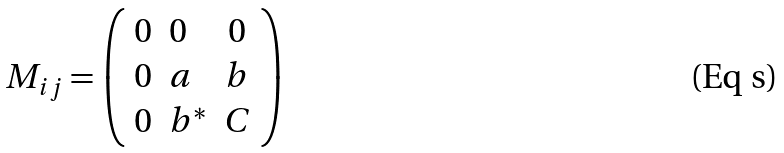<formula> <loc_0><loc_0><loc_500><loc_500>M _ { i j } = \left ( \begin{array} { c l c } 0 & 0 & 0 \\ 0 & a & b \\ 0 & b ^ { * } & C \end{array} \right )</formula> 